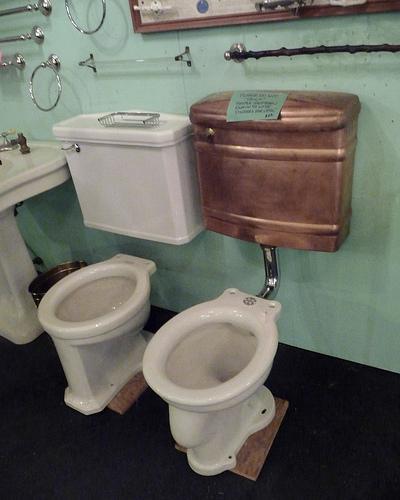How many rings can you see?
Give a very brief answer. 2. 